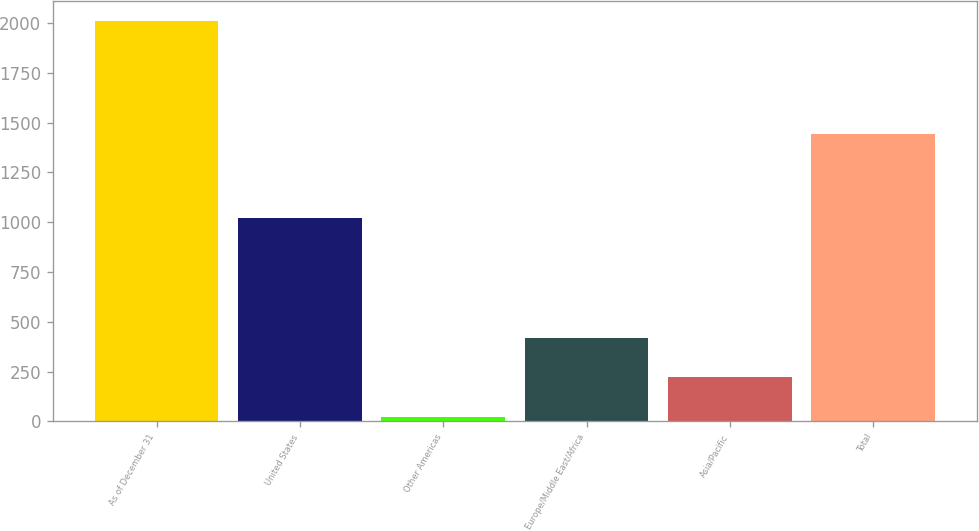Convert chart. <chart><loc_0><loc_0><loc_500><loc_500><bar_chart><fcel>As of December 31<fcel>United States<fcel>Other Americas<fcel>Europe/Middle East/Africa<fcel>Asia/Pacific<fcel>Total<nl><fcel>2008<fcel>1020<fcel>24<fcel>420.8<fcel>222.4<fcel>1444<nl></chart> 